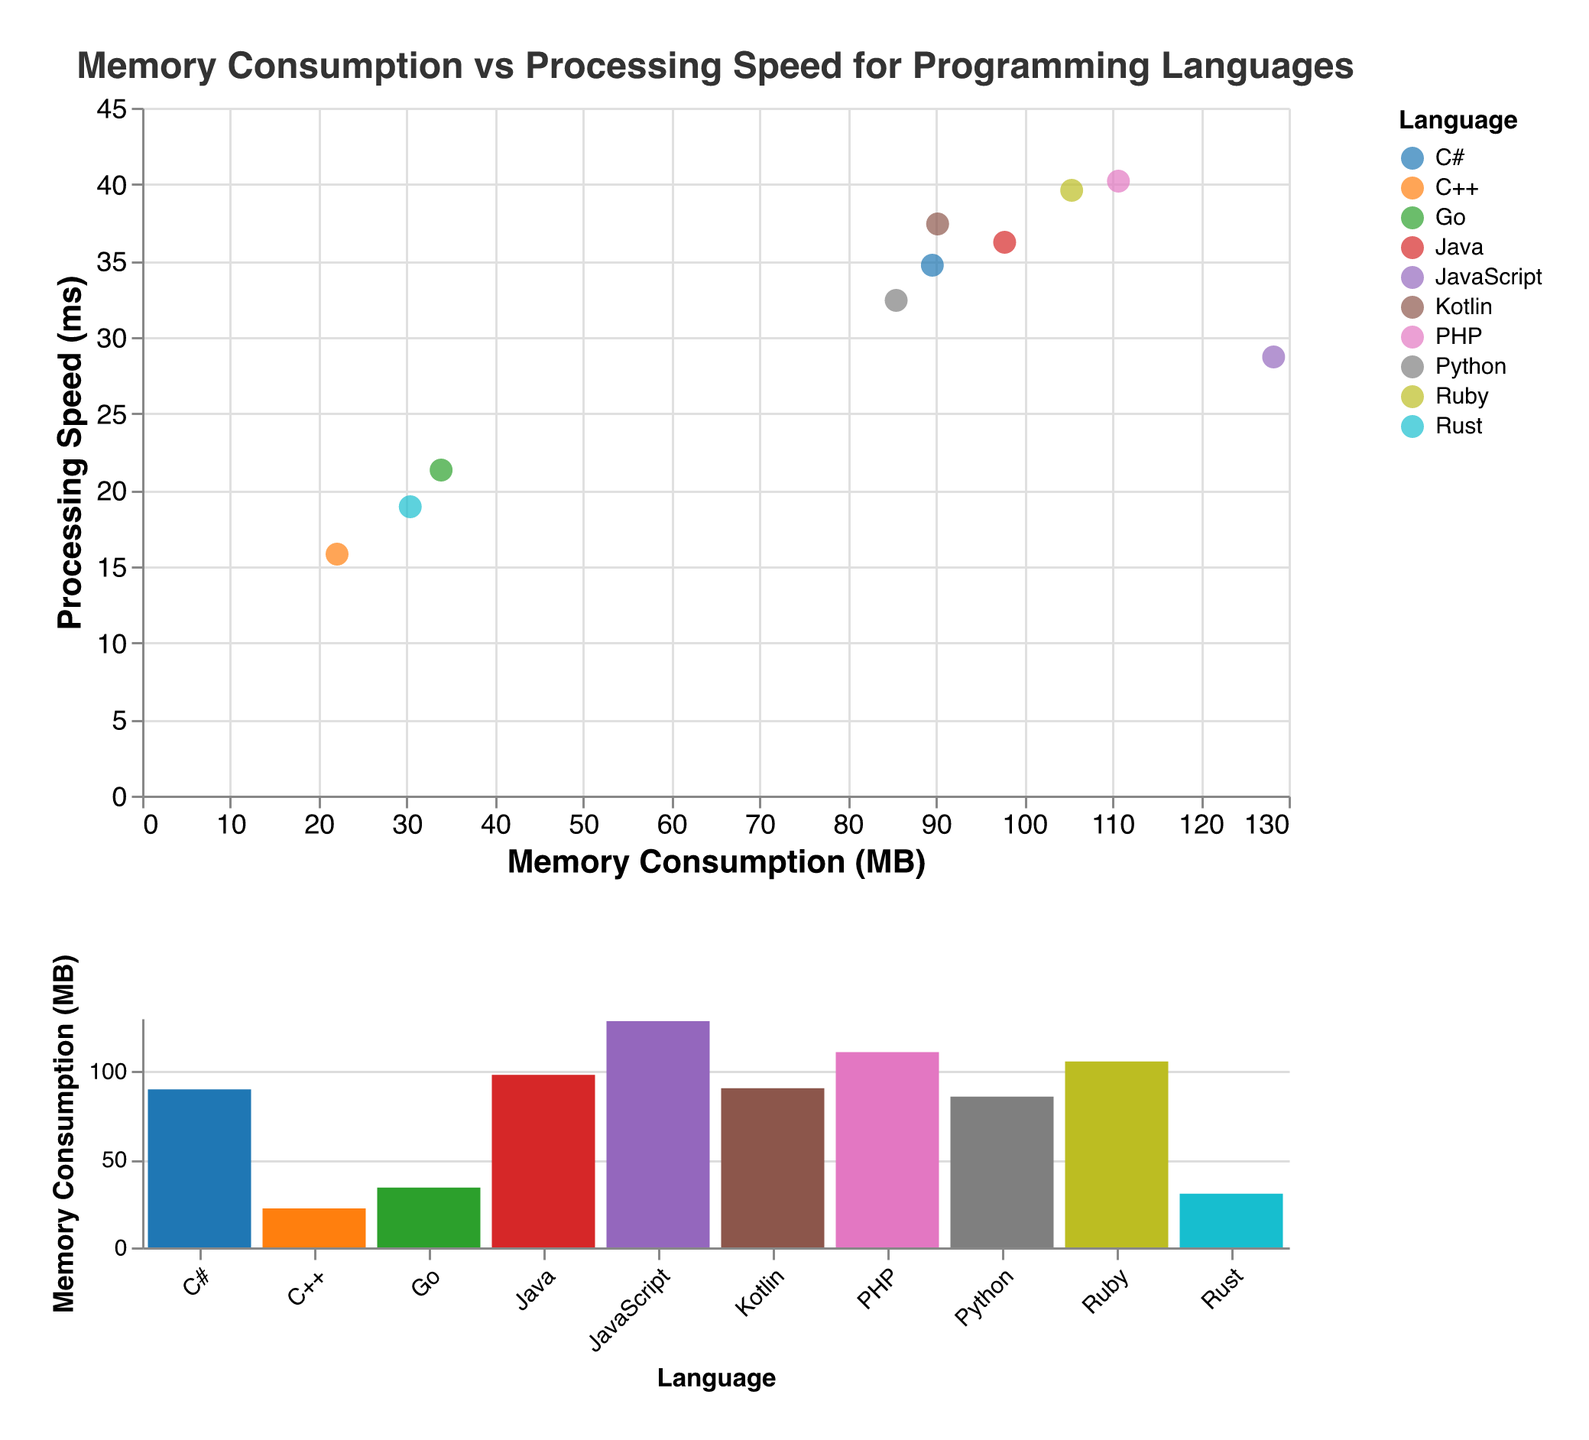What does the title of the scatter plot indicate? The title "Memory Consumption vs Processing Speed for Programming Languages" indicates that the scatter plot compares memory consumption (in MB) with processing speed (in ms) for different programming languages.
Answer: Memory Consumption vs Processing Speed for Programming Languages What programming language has the highest memory consumption? By examining the y-axis of the bar chart, JavaScript has the highest bar, signifying the highest memory consumption among all plotted languages.
Answer: JavaScript Which language is the fastest in terms of processing speed? By looking at the scatter plot, C++ has the lowest processing speed value on the y-axis, indicating it is the fastest.
Answer: C++ What are the memory consumption and processing speed values for Rust? Hovering over the point representing Rust in the scatter plot, the tooltip shows its memory consumption is 30.4 MB and its processing speed is 18.9 ms.
Answer: 30.4 MB, 18.9 ms How does Python compare to Java in terms of memory consumption? From the scatter plot, Python with 85.5 MB consumes less memory than Java which has 97.8 MB.
Answer: Python consumes less memory than Java Which programming language has the highest processing speed but moderate memory consumption? Observing the scatter plot, C++ has the highest processing speed (lowest value) of 15.8 ms and moderate memory consumption at 22.1 MB.
Answer: C++ Compare the memory consumption of PHP and Ruby. Which one is higher and by how much? Referring to the values in the bar chart, PHP (110.7 MB) has higher memory consumption than Ruby (105.4 MB). The difference is 110.7 - 105.4 = 5.3 MB
Answer: PHP, by 5.3 MB What's the average processing speed across all languages shown? Add all processing speeds: 32.4 + 28.7 + 36.2 + 15.8 + 39.6 + 21.3 + 34.7 + 40.2 + 18.9 + 37.4 = 305.2 ms. Divide by the number of languages (10): 305.2 / 10 = 30.52 ms.
Answer: 30.52 ms What is the quadrants distribution of the languages in terms of memory and processing speed? Divide the scatter plot into four quadrants along the median of memory (~90.2 MB) and processing speed (~30.5 ms): C++, Go, Rust fall into low memory & high speed; Python, Java, C#, Kotlin, Ruby, PHP are in high memory & low speed; JavaScript holds the unique position above others in memory but below average process speed.
Answer: Varied distribution across quadrants 